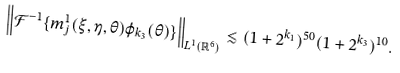<formula> <loc_0><loc_0><loc_500><loc_500>\left \| \mathcal { F } ^ { - 1 } \{ m ^ { 1 } _ { j } ( \xi , \eta , \theta ) \varphi _ { k _ { 3 } } ( \theta ) \} \right \| _ { L ^ { 1 } ( \mathbb { R } ^ { 6 } ) } \lesssim ( 1 + 2 ^ { k _ { 1 } } ) ^ { 5 0 } ( 1 + 2 ^ { k _ { 3 } } ) ^ { 1 0 } .</formula> 